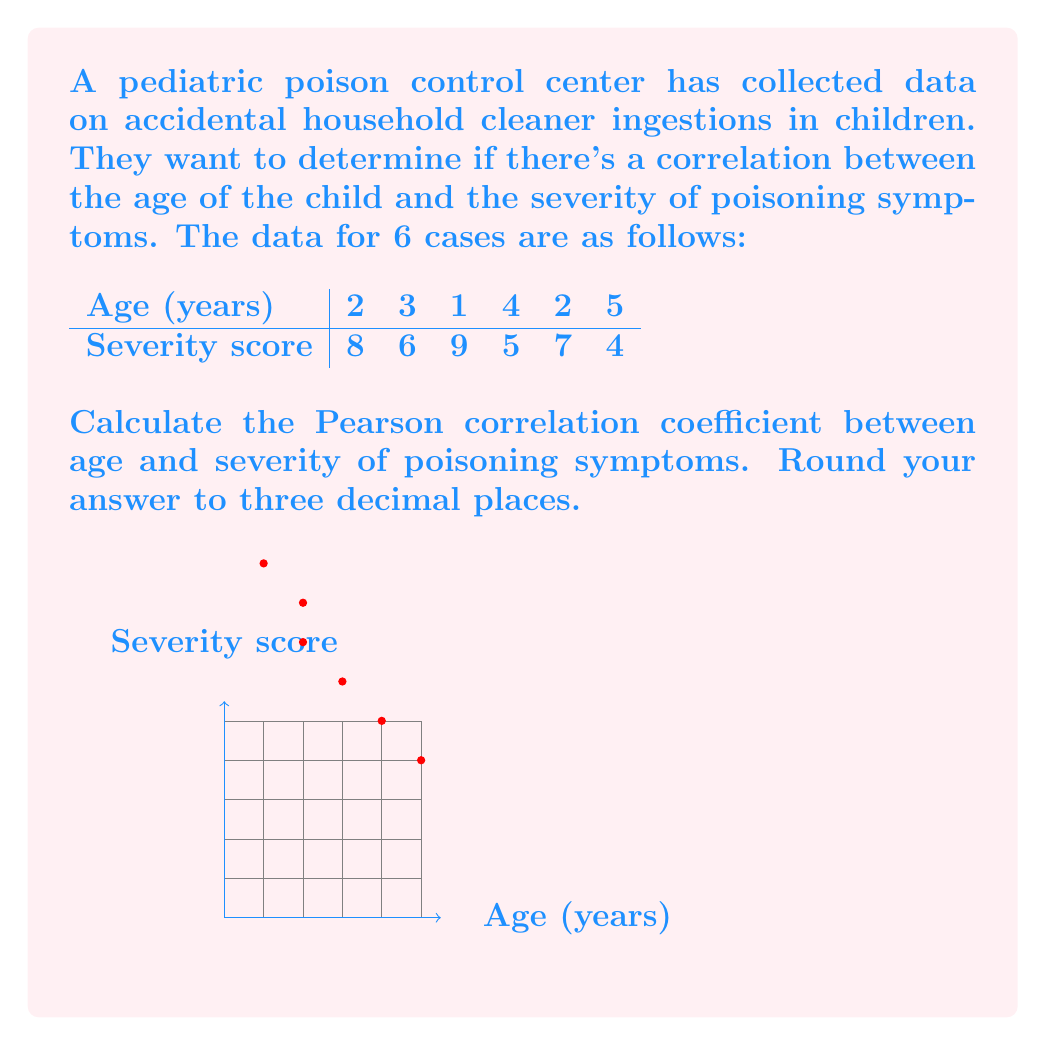Give your solution to this math problem. To calculate the Pearson correlation coefficient, we'll follow these steps:

1) First, let's calculate the means for age ($\bar{x}$) and severity ($\bar{y}$):

   $\bar{x} = \frac{2+3+1+4+2+5}{6} = \frac{17}{6} = 2.833$
   $\bar{y} = \frac{8+6+9+5+7+4}{6} = \frac{39}{6} = 6.5$

2) Now, we need to calculate the following sums:
   $\sum(x-\bar{x})(y-\bar{y})$, $\sum(x-\bar{x})^2$, and $\sum(y-\bar{y})^2$

3) Let's create a table to help with calculations:

   | x | y | x-$\bar{x}$ | y-$\bar{y}$ | (x-$\bar{x}$)(y-$\bar{y}$) | (x-$\bar{x}$)^2 | (y-$\bar{y}$)^2 |
   |---|---|-------------|-------------|---------------------------|-----------------|-----------------|
   | 2 | 8 | -0.833      | 1.5         | -1.2495                   | 0.693889        | 2.25            |
   | 3 | 6 | 0.167       | -0.5        | -0.0835                   | 0.027889        | 0.25            |
   | 1 | 9 | -1.833      | 2.5         | -4.5825                   | 3.359889        | 6.25            |
   | 4 | 5 | 1.167       | -1.5        | -1.7505                   | 1.361889        | 2.25            |
   | 2 | 7 | -0.833      | 0.5         | -0.4165                   | 0.693889        | 0.25            |
   | 5 | 4 | 2.167       | -2.5        | -5.4175                   | 4.695889        | 6.25            |

4) Sum up the columns:
   $\sum(x-\bar{x})(y-\bar{y}) = -13.5$
   $\sum(x-\bar{x})^2 = 10.833334$
   $\sum(y-\bar{y})^2 = 17.5$

5) Now we can apply the formula for Pearson correlation coefficient:

   $$r = \frac{\sum(x-\bar{x})(y-\bar{y})}{\sqrt{\sum(x-\bar{x})^2 \sum(y-\bar{y})^2}}$$

   $$r = \frac{-13.5}{\sqrt{10.833334 * 17.5}} = \frac{-13.5}{\sqrt{189.583345}} = \frac{-13.5}{13.76892}$$

6) Calculate and round to three decimal places:
   $r = -0.980$
Answer: $-0.980$ 